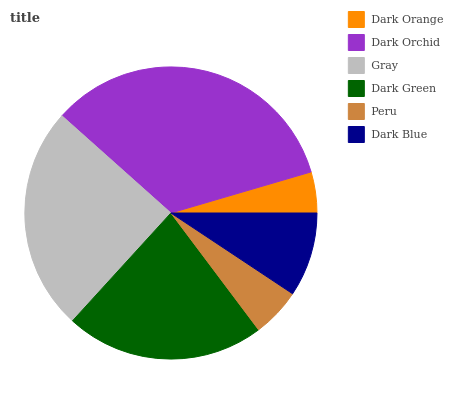Is Dark Orange the minimum?
Answer yes or no. Yes. Is Dark Orchid the maximum?
Answer yes or no. Yes. Is Gray the minimum?
Answer yes or no. No. Is Gray the maximum?
Answer yes or no. No. Is Dark Orchid greater than Gray?
Answer yes or no. Yes. Is Gray less than Dark Orchid?
Answer yes or no. Yes. Is Gray greater than Dark Orchid?
Answer yes or no. No. Is Dark Orchid less than Gray?
Answer yes or no. No. Is Dark Green the high median?
Answer yes or no. Yes. Is Dark Blue the low median?
Answer yes or no. Yes. Is Dark Blue the high median?
Answer yes or no. No. Is Dark Orange the low median?
Answer yes or no. No. 